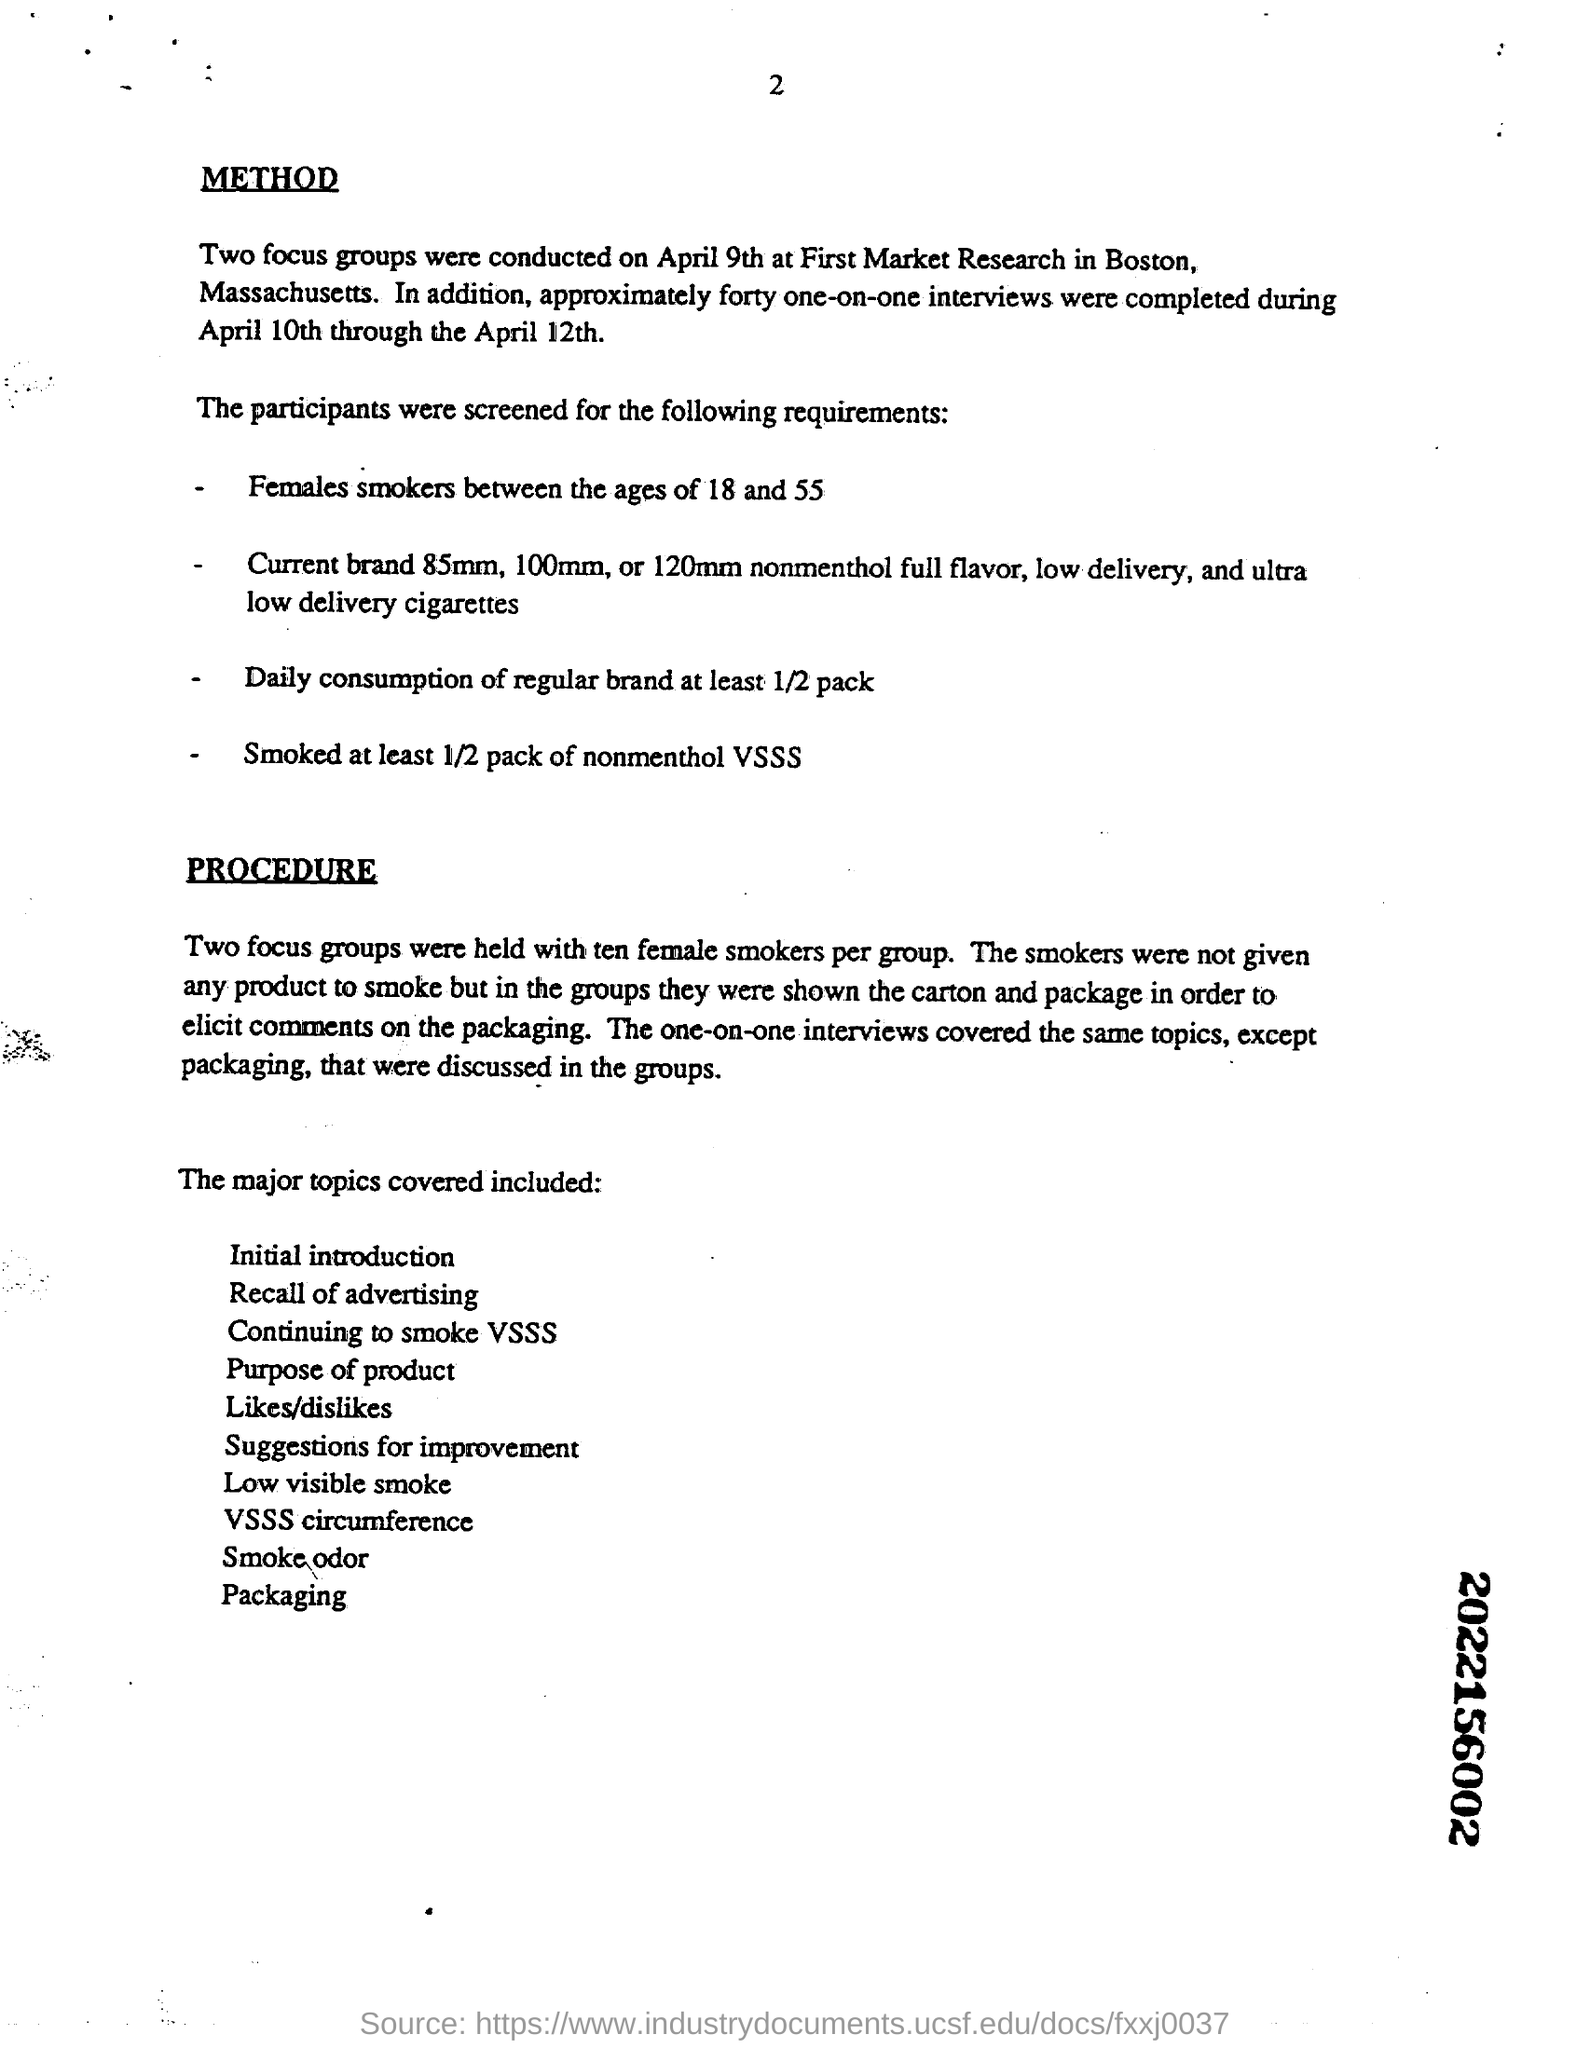How many one-on-one  interviews were completed during April 10th through the April 12th?
 forty 